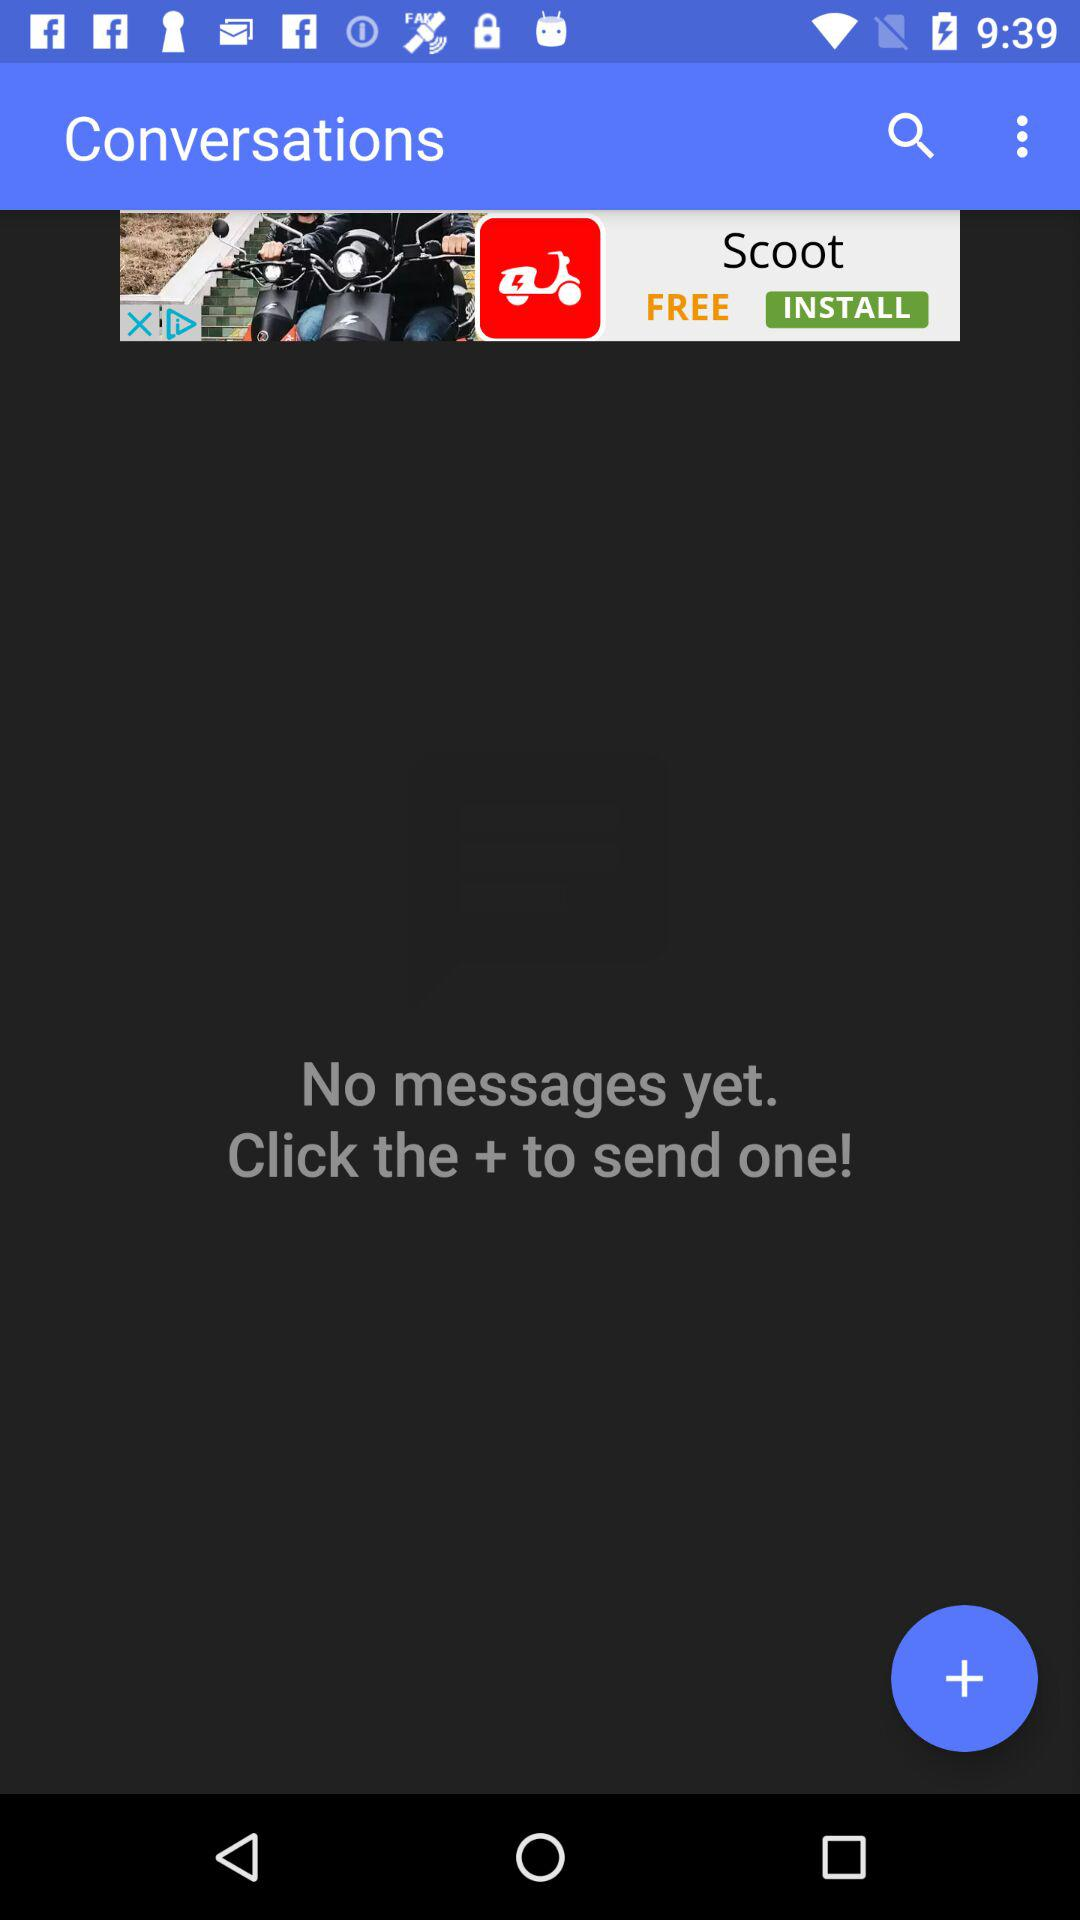Are there any messages? There are no messages. 